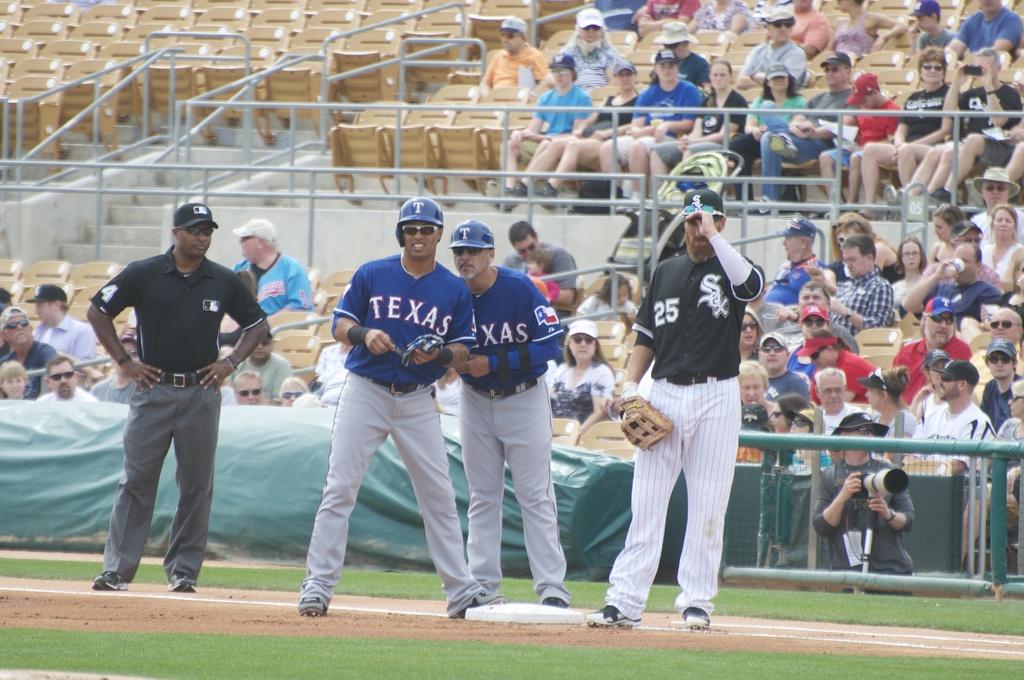What state team name is represented in the blue jerseys?
Make the answer very short. Texas. What number is the player in black?
Provide a short and direct response. 25. 